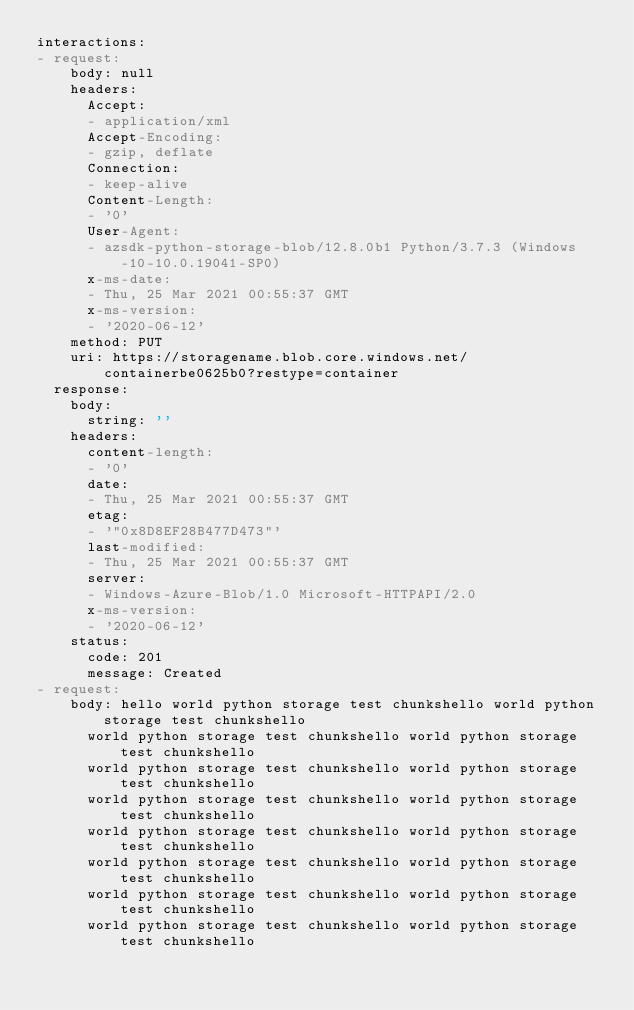<code> <loc_0><loc_0><loc_500><loc_500><_YAML_>interactions:
- request:
    body: null
    headers:
      Accept:
      - application/xml
      Accept-Encoding:
      - gzip, deflate
      Connection:
      - keep-alive
      Content-Length:
      - '0'
      User-Agent:
      - azsdk-python-storage-blob/12.8.0b1 Python/3.7.3 (Windows-10-10.0.19041-SP0)
      x-ms-date:
      - Thu, 25 Mar 2021 00:55:37 GMT
      x-ms-version:
      - '2020-06-12'
    method: PUT
    uri: https://storagename.blob.core.windows.net/containerbe0625b0?restype=container
  response:
    body:
      string: ''
    headers:
      content-length:
      - '0'
      date:
      - Thu, 25 Mar 2021 00:55:37 GMT
      etag:
      - '"0x8D8EF28B477D473"'
      last-modified:
      - Thu, 25 Mar 2021 00:55:37 GMT
      server:
      - Windows-Azure-Blob/1.0 Microsoft-HTTPAPI/2.0
      x-ms-version:
      - '2020-06-12'
    status:
      code: 201
      message: Created
- request:
    body: hello world python storage test chunkshello world python storage test chunkshello
      world python storage test chunkshello world python storage test chunkshello
      world python storage test chunkshello world python storage test chunkshello
      world python storage test chunkshello world python storage test chunkshello
      world python storage test chunkshello world python storage test chunkshello
      world python storage test chunkshello world python storage test chunkshello
      world python storage test chunkshello world python storage test chunkshello
      world python storage test chunkshello world python storage test chunkshello</code> 